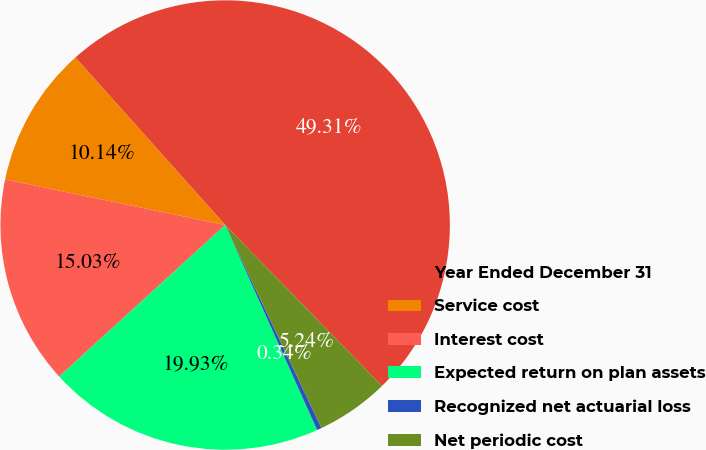<chart> <loc_0><loc_0><loc_500><loc_500><pie_chart><fcel>Year Ended December 31<fcel>Service cost<fcel>Interest cost<fcel>Expected return on plan assets<fcel>Recognized net actuarial loss<fcel>Net periodic cost<nl><fcel>49.31%<fcel>10.14%<fcel>15.03%<fcel>19.93%<fcel>0.34%<fcel>5.24%<nl></chart> 